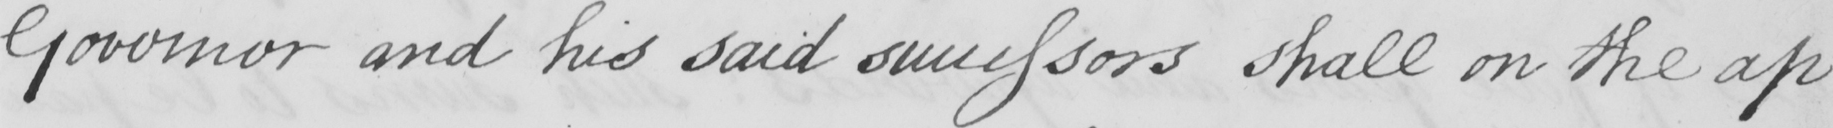What text is written in this handwritten line? Governor and his said successors shall on the ap- 